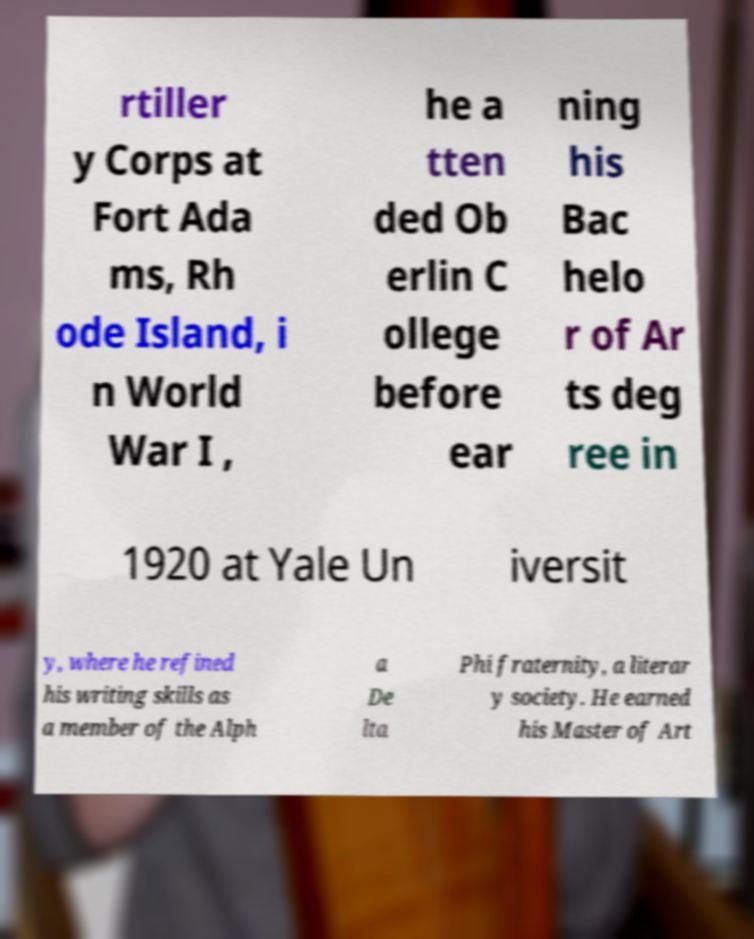Can you read and provide the text displayed in the image?This photo seems to have some interesting text. Can you extract and type it out for me? rtiller y Corps at Fort Ada ms, Rh ode Island, i n World War I , he a tten ded Ob erlin C ollege before ear ning his Bac helo r of Ar ts deg ree in 1920 at Yale Un iversit y, where he refined his writing skills as a member of the Alph a De lta Phi fraternity, a literar y society. He earned his Master of Art 